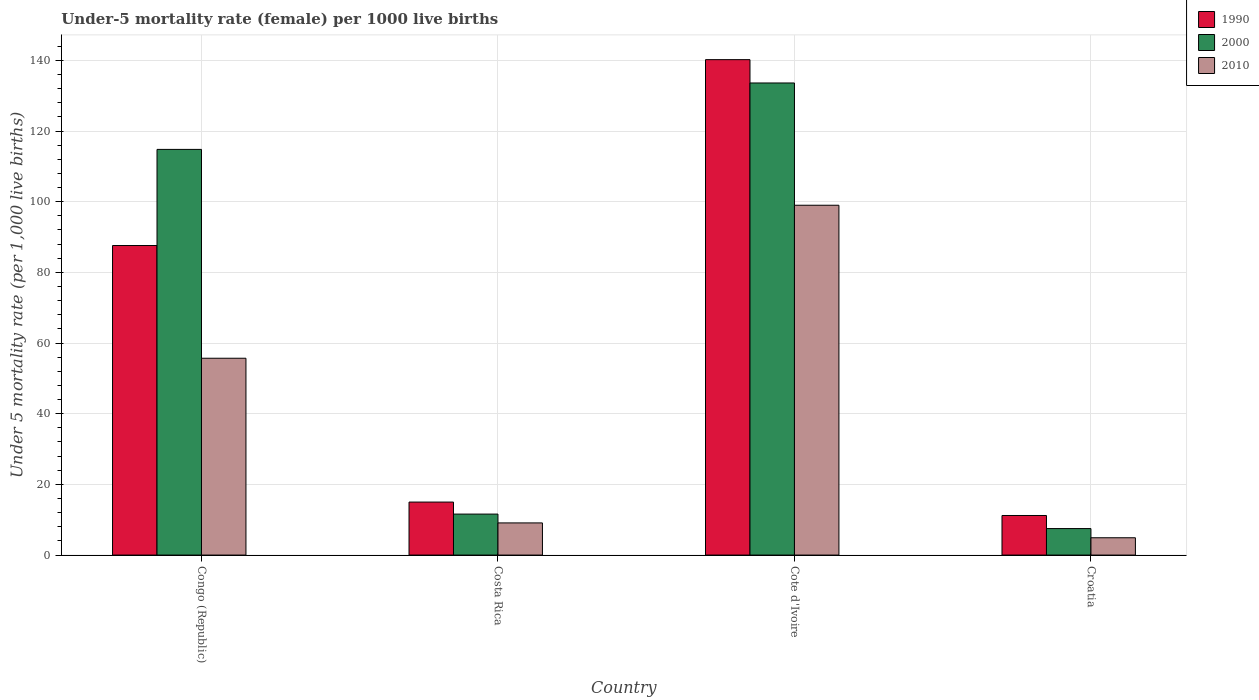Are the number of bars per tick equal to the number of legend labels?
Provide a short and direct response. Yes. Are the number of bars on each tick of the X-axis equal?
Provide a short and direct response. Yes. How many bars are there on the 4th tick from the right?
Your answer should be compact. 3. What is the label of the 3rd group of bars from the left?
Offer a very short reply. Cote d'Ivoire. What is the under-five mortality rate in 2000 in Cote d'Ivoire?
Keep it short and to the point. 133.6. Across all countries, what is the maximum under-five mortality rate in 2010?
Provide a short and direct response. 99. Across all countries, what is the minimum under-five mortality rate in 2000?
Offer a terse response. 7.5. In which country was the under-five mortality rate in 2000 maximum?
Ensure brevity in your answer.  Cote d'Ivoire. In which country was the under-five mortality rate in 2010 minimum?
Your answer should be very brief. Croatia. What is the total under-five mortality rate in 1990 in the graph?
Provide a succinct answer. 254. What is the difference between the under-five mortality rate in 2000 in Costa Rica and the under-five mortality rate in 2010 in Congo (Republic)?
Keep it short and to the point. -44.1. What is the average under-five mortality rate in 2000 per country?
Give a very brief answer. 66.88. What is the difference between the under-five mortality rate of/in 2000 and under-five mortality rate of/in 2010 in Congo (Republic)?
Your response must be concise. 59.1. In how many countries, is the under-five mortality rate in 2000 greater than 120?
Your answer should be compact. 1. What is the ratio of the under-five mortality rate in 1990 in Congo (Republic) to that in Croatia?
Your answer should be very brief. 7.82. Is the under-five mortality rate in 1990 in Cote d'Ivoire less than that in Croatia?
Your response must be concise. No. What is the difference between the highest and the second highest under-five mortality rate in 1990?
Make the answer very short. 125.2. What is the difference between the highest and the lowest under-five mortality rate in 1990?
Ensure brevity in your answer.  129. In how many countries, is the under-five mortality rate in 2000 greater than the average under-five mortality rate in 2000 taken over all countries?
Offer a terse response. 2. Is the sum of the under-five mortality rate in 2000 in Congo (Republic) and Costa Rica greater than the maximum under-five mortality rate in 2010 across all countries?
Provide a succinct answer. Yes. What does the 1st bar from the left in Cote d'Ivoire represents?
Provide a succinct answer. 1990. What is the difference between two consecutive major ticks on the Y-axis?
Make the answer very short. 20. Does the graph contain any zero values?
Your response must be concise. No. Where does the legend appear in the graph?
Offer a very short reply. Top right. How many legend labels are there?
Your answer should be very brief. 3. What is the title of the graph?
Provide a short and direct response. Under-5 mortality rate (female) per 1000 live births. Does "1991" appear as one of the legend labels in the graph?
Your answer should be compact. No. What is the label or title of the Y-axis?
Your response must be concise. Under 5 mortality rate (per 1,0 live births). What is the Under 5 mortality rate (per 1,000 live births) of 1990 in Congo (Republic)?
Your answer should be very brief. 87.6. What is the Under 5 mortality rate (per 1,000 live births) of 2000 in Congo (Republic)?
Keep it short and to the point. 114.8. What is the Under 5 mortality rate (per 1,000 live births) in 2010 in Congo (Republic)?
Ensure brevity in your answer.  55.7. What is the Under 5 mortality rate (per 1,000 live births) of 2010 in Costa Rica?
Provide a short and direct response. 9.1. What is the Under 5 mortality rate (per 1,000 live births) in 1990 in Cote d'Ivoire?
Make the answer very short. 140.2. What is the Under 5 mortality rate (per 1,000 live births) in 2000 in Cote d'Ivoire?
Keep it short and to the point. 133.6. What is the Under 5 mortality rate (per 1,000 live births) of 2010 in Cote d'Ivoire?
Offer a terse response. 99. What is the Under 5 mortality rate (per 1,000 live births) in 2000 in Croatia?
Provide a succinct answer. 7.5. Across all countries, what is the maximum Under 5 mortality rate (per 1,000 live births) in 1990?
Your answer should be compact. 140.2. Across all countries, what is the maximum Under 5 mortality rate (per 1,000 live births) in 2000?
Your response must be concise. 133.6. Across all countries, what is the maximum Under 5 mortality rate (per 1,000 live births) in 2010?
Provide a short and direct response. 99. Across all countries, what is the minimum Under 5 mortality rate (per 1,000 live births) in 2000?
Keep it short and to the point. 7.5. Across all countries, what is the minimum Under 5 mortality rate (per 1,000 live births) of 2010?
Your answer should be compact. 4.9. What is the total Under 5 mortality rate (per 1,000 live births) of 1990 in the graph?
Give a very brief answer. 254. What is the total Under 5 mortality rate (per 1,000 live births) in 2000 in the graph?
Make the answer very short. 267.5. What is the total Under 5 mortality rate (per 1,000 live births) in 2010 in the graph?
Provide a succinct answer. 168.7. What is the difference between the Under 5 mortality rate (per 1,000 live births) in 1990 in Congo (Republic) and that in Costa Rica?
Keep it short and to the point. 72.6. What is the difference between the Under 5 mortality rate (per 1,000 live births) in 2000 in Congo (Republic) and that in Costa Rica?
Provide a short and direct response. 103.2. What is the difference between the Under 5 mortality rate (per 1,000 live births) in 2010 in Congo (Republic) and that in Costa Rica?
Your response must be concise. 46.6. What is the difference between the Under 5 mortality rate (per 1,000 live births) of 1990 in Congo (Republic) and that in Cote d'Ivoire?
Offer a terse response. -52.6. What is the difference between the Under 5 mortality rate (per 1,000 live births) of 2000 in Congo (Republic) and that in Cote d'Ivoire?
Your response must be concise. -18.8. What is the difference between the Under 5 mortality rate (per 1,000 live births) in 2010 in Congo (Republic) and that in Cote d'Ivoire?
Provide a short and direct response. -43.3. What is the difference between the Under 5 mortality rate (per 1,000 live births) of 1990 in Congo (Republic) and that in Croatia?
Keep it short and to the point. 76.4. What is the difference between the Under 5 mortality rate (per 1,000 live births) in 2000 in Congo (Republic) and that in Croatia?
Provide a succinct answer. 107.3. What is the difference between the Under 5 mortality rate (per 1,000 live births) of 2010 in Congo (Republic) and that in Croatia?
Your answer should be very brief. 50.8. What is the difference between the Under 5 mortality rate (per 1,000 live births) in 1990 in Costa Rica and that in Cote d'Ivoire?
Offer a terse response. -125.2. What is the difference between the Under 5 mortality rate (per 1,000 live births) of 2000 in Costa Rica and that in Cote d'Ivoire?
Make the answer very short. -122. What is the difference between the Under 5 mortality rate (per 1,000 live births) of 2010 in Costa Rica and that in Cote d'Ivoire?
Keep it short and to the point. -89.9. What is the difference between the Under 5 mortality rate (per 1,000 live births) in 2000 in Costa Rica and that in Croatia?
Offer a terse response. 4.1. What is the difference between the Under 5 mortality rate (per 1,000 live births) of 2010 in Costa Rica and that in Croatia?
Your response must be concise. 4.2. What is the difference between the Under 5 mortality rate (per 1,000 live births) of 1990 in Cote d'Ivoire and that in Croatia?
Make the answer very short. 129. What is the difference between the Under 5 mortality rate (per 1,000 live births) in 2000 in Cote d'Ivoire and that in Croatia?
Offer a terse response. 126.1. What is the difference between the Under 5 mortality rate (per 1,000 live births) of 2010 in Cote d'Ivoire and that in Croatia?
Ensure brevity in your answer.  94.1. What is the difference between the Under 5 mortality rate (per 1,000 live births) of 1990 in Congo (Republic) and the Under 5 mortality rate (per 1,000 live births) of 2000 in Costa Rica?
Your response must be concise. 76. What is the difference between the Under 5 mortality rate (per 1,000 live births) in 1990 in Congo (Republic) and the Under 5 mortality rate (per 1,000 live births) in 2010 in Costa Rica?
Keep it short and to the point. 78.5. What is the difference between the Under 5 mortality rate (per 1,000 live births) of 2000 in Congo (Republic) and the Under 5 mortality rate (per 1,000 live births) of 2010 in Costa Rica?
Offer a terse response. 105.7. What is the difference between the Under 5 mortality rate (per 1,000 live births) of 1990 in Congo (Republic) and the Under 5 mortality rate (per 1,000 live births) of 2000 in Cote d'Ivoire?
Your response must be concise. -46. What is the difference between the Under 5 mortality rate (per 1,000 live births) in 1990 in Congo (Republic) and the Under 5 mortality rate (per 1,000 live births) in 2000 in Croatia?
Make the answer very short. 80.1. What is the difference between the Under 5 mortality rate (per 1,000 live births) of 1990 in Congo (Republic) and the Under 5 mortality rate (per 1,000 live births) of 2010 in Croatia?
Keep it short and to the point. 82.7. What is the difference between the Under 5 mortality rate (per 1,000 live births) of 2000 in Congo (Republic) and the Under 5 mortality rate (per 1,000 live births) of 2010 in Croatia?
Make the answer very short. 109.9. What is the difference between the Under 5 mortality rate (per 1,000 live births) of 1990 in Costa Rica and the Under 5 mortality rate (per 1,000 live births) of 2000 in Cote d'Ivoire?
Your answer should be compact. -118.6. What is the difference between the Under 5 mortality rate (per 1,000 live births) of 1990 in Costa Rica and the Under 5 mortality rate (per 1,000 live births) of 2010 in Cote d'Ivoire?
Offer a terse response. -84. What is the difference between the Under 5 mortality rate (per 1,000 live births) of 2000 in Costa Rica and the Under 5 mortality rate (per 1,000 live births) of 2010 in Cote d'Ivoire?
Provide a short and direct response. -87.4. What is the difference between the Under 5 mortality rate (per 1,000 live births) in 1990 in Cote d'Ivoire and the Under 5 mortality rate (per 1,000 live births) in 2000 in Croatia?
Your answer should be compact. 132.7. What is the difference between the Under 5 mortality rate (per 1,000 live births) of 1990 in Cote d'Ivoire and the Under 5 mortality rate (per 1,000 live births) of 2010 in Croatia?
Give a very brief answer. 135.3. What is the difference between the Under 5 mortality rate (per 1,000 live births) of 2000 in Cote d'Ivoire and the Under 5 mortality rate (per 1,000 live births) of 2010 in Croatia?
Keep it short and to the point. 128.7. What is the average Under 5 mortality rate (per 1,000 live births) in 1990 per country?
Offer a terse response. 63.5. What is the average Under 5 mortality rate (per 1,000 live births) in 2000 per country?
Provide a short and direct response. 66.88. What is the average Under 5 mortality rate (per 1,000 live births) of 2010 per country?
Offer a very short reply. 42.17. What is the difference between the Under 5 mortality rate (per 1,000 live births) in 1990 and Under 5 mortality rate (per 1,000 live births) in 2000 in Congo (Republic)?
Your answer should be very brief. -27.2. What is the difference between the Under 5 mortality rate (per 1,000 live births) in 1990 and Under 5 mortality rate (per 1,000 live births) in 2010 in Congo (Republic)?
Provide a short and direct response. 31.9. What is the difference between the Under 5 mortality rate (per 1,000 live births) of 2000 and Under 5 mortality rate (per 1,000 live births) of 2010 in Congo (Republic)?
Ensure brevity in your answer.  59.1. What is the difference between the Under 5 mortality rate (per 1,000 live births) of 1990 and Under 5 mortality rate (per 1,000 live births) of 2010 in Costa Rica?
Provide a succinct answer. 5.9. What is the difference between the Under 5 mortality rate (per 1,000 live births) in 1990 and Under 5 mortality rate (per 1,000 live births) in 2010 in Cote d'Ivoire?
Provide a short and direct response. 41.2. What is the difference between the Under 5 mortality rate (per 1,000 live births) of 2000 and Under 5 mortality rate (per 1,000 live births) of 2010 in Cote d'Ivoire?
Your answer should be compact. 34.6. What is the difference between the Under 5 mortality rate (per 1,000 live births) of 1990 and Under 5 mortality rate (per 1,000 live births) of 2010 in Croatia?
Your answer should be compact. 6.3. What is the difference between the Under 5 mortality rate (per 1,000 live births) of 2000 and Under 5 mortality rate (per 1,000 live births) of 2010 in Croatia?
Your answer should be very brief. 2.6. What is the ratio of the Under 5 mortality rate (per 1,000 live births) in 1990 in Congo (Republic) to that in Costa Rica?
Provide a succinct answer. 5.84. What is the ratio of the Under 5 mortality rate (per 1,000 live births) of 2000 in Congo (Republic) to that in Costa Rica?
Ensure brevity in your answer.  9.9. What is the ratio of the Under 5 mortality rate (per 1,000 live births) of 2010 in Congo (Republic) to that in Costa Rica?
Your answer should be very brief. 6.12. What is the ratio of the Under 5 mortality rate (per 1,000 live births) of 1990 in Congo (Republic) to that in Cote d'Ivoire?
Ensure brevity in your answer.  0.62. What is the ratio of the Under 5 mortality rate (per 1,000 live births) in 2000 in Congo (Republic) to that in Cote d'Ivoire?
Ensure brevity in your answer.  0.86. What is the ratio of the Under 5 mortality rate (per 1,000 live births) in 2010 in Congo (Republic) to that in Cote d'Ivoire?
Keep it short and to the point. 0.56. What is the ratio of the Under 5 mortality rate (per 1,000 live births) of 1990 in Congo (Republic) to that in Croatia?
Give a very brief answer. 7.82. What is the ratio of the Under 5 mortality rate (per 1,000 live births) in 2000 in Congo (Republic) to that in Croatia?
Provide a short and direct response. 15.31. What is the ratio of the Under 5 mortality rate (per 1,000 live births) in 2010 in Congo (Republic) to that in Croatia?
Provide a short and direct response. 11.37. What is the ratio of the Under 5 mortality rate (per 1,000 live births) of 1990 in Costa Rica to that in Cote d'Ivoire?
Offer a terse response. 0.11. What is the ratio of the Under 5 mortality rate (per 1,000 live births) of 2000 in Costa Rica to that in Cote d'Ivoire?
Provide a succinct answer. 0.09. What is the ratio of the Under 5 mortality rate (per 1,000 live births) in 2010 in Costa Rica to that in Cote d'Ivoire?
Your response must be concise. 0.09. What is the ratio of the Under 5 mortality rate (per 1,000 live births) in 1990 in Costa Rica to that in Croatia?
Give a very brief answer. 1.34. What is the ratio of the Under 5 mortality rate (per 1,000 live births) of 2000 in Costa Rica to that in Croatia?
Ensure brevity in your answer.  1.55. What is the ratio of the Under 5 mortality rate (per 1,000 live births) of 2010 in Costa Rica to that in Croatia?
Offer a very short reply. 1.86. What is the ratio of the Under 5 mortality rate (per 1,000 live births) in 1990 in Cote d'Ivoire to that in Croatia?
Give a very brief answer. 12.52. What is the ratio of the Under 5 mortality rate (per 1,000 live births) in 2000 in Cote d'Ivoire to that in Croatia?
Your answer should be very brief. 17.81. What is the ratio of the Under 5 mortality rate (per 1,000 live births) in 2010 in Cote d'Ivoire to that in Croatia?
Your answer should be compact. 20.2. What is the difference between the highest and the second highest Under 5 mortality rate (per 1,000 live births) of 1990?
Your answer should be compact. 52.6. What is the difference between the highest and the second highest Under 5 mortality rate (per 1,000 live births) in 2010?
Provide a short and direct response. 43.3. What is the difference between the highest and the lowest Under 5 mortality rate (per 1,000 live births) in 1990?
Offer a terse response. 129. What is the difference between the highest and the lowest Under 5 mortality rate (per 1,000 live births) of 2000?
Make the answer very short. 126.1. What is the difference between the highest and the lowest Under 5 mortality rate (per 1,000 live births) in 2010?
Provide a succinct answer. 94.1. 